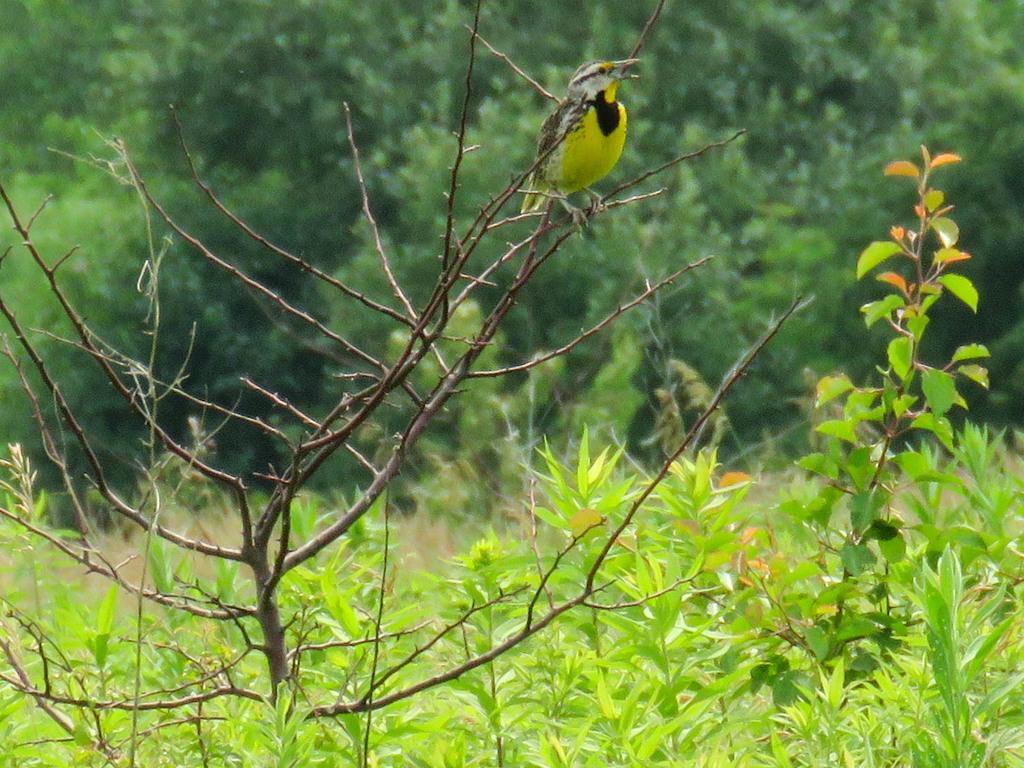How would you summarize this image in a sentence or two? There is a bird standing on the branch of a plant near other plants. In the background, there are plants and trees on the ground. 